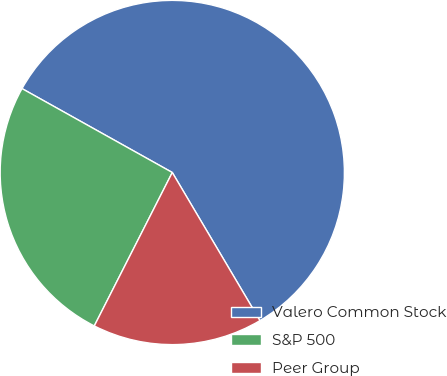<chart> <loc_0><loc_0><loc_500><loc_500><pie_chart><fcel>Valero Common Stock<fcel>S&P 500<fcel>Peer Group<nl><fcel>58.39%<fcel>25.62%<fcel>15.99%<nl></chart> 